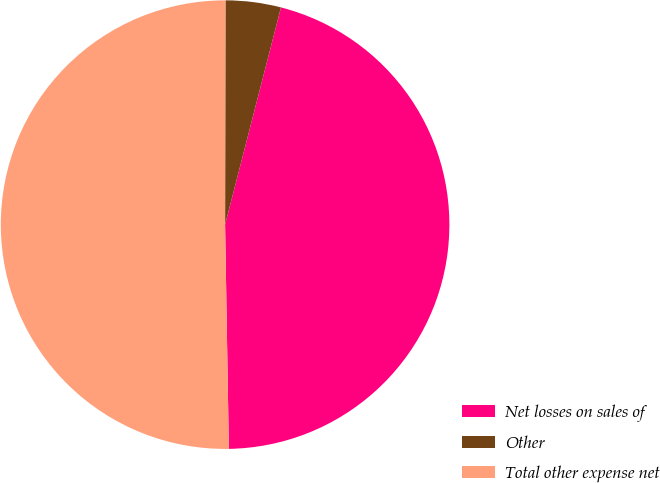Convert chart. <chart><loc_0><loc_0><loc_500><loc_500><pie_chart><fcel>Net losses on sales of<fcel>Other<fcel>Total other expense net<nl><fcel>45.72%<fcel>3.98%<fcel>50.29%<nl></chart> 